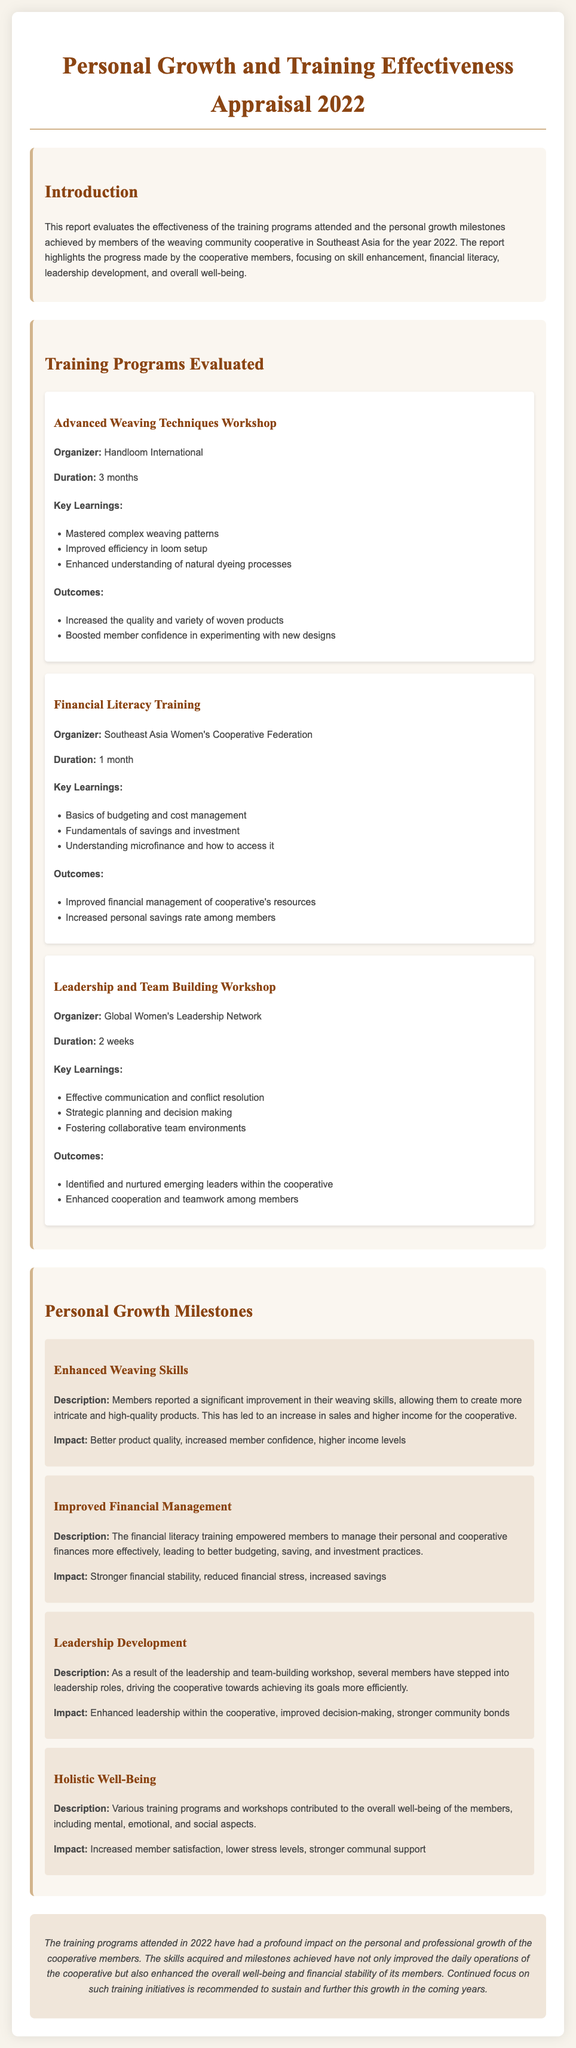what is the title of the report? The title of the report is prominently stated at the top of the document.
Answer: Personal Growth and Training Effectiveness Appraisal 2022 who organized the Advanced Weaving Techniques Workshop? The organizer of the workshop is mentioned under the program details.
Answer: Handloom International how long did the Financial Literacy Training last? The duration is specified in the details of the training program.
Answer: 1 month what was a key learning from the Leadership and Team Building Workshop? Key learnings are listed within the respective program section.
Answer: Effective communication and conflict resolution what outcome resulted from the Advanced Weaving Techniques Workshop? Outcomes are highlighted, showing the effects of the training.
Answer: Increased the quality and variety of woven products how many personal growth milestones are mentioned in the document? The number of milestones is counted in the Personal Growth Milestones section.
Answer: 4 what impact did the Improved Financial Management milestone have? The impact is described in relation to the financial management improvements.
Answer: Stronger financial stability what training program focused on mental, emotional, and social aspects? The description of holistic development is mentioned under personal growth milestones.
Answer: Holistic Well-Being who organized the Financial Literacy Training? The organizer of the training is listed in the program details.
Answer: Southeast Asia Women's Cooperative Federation 